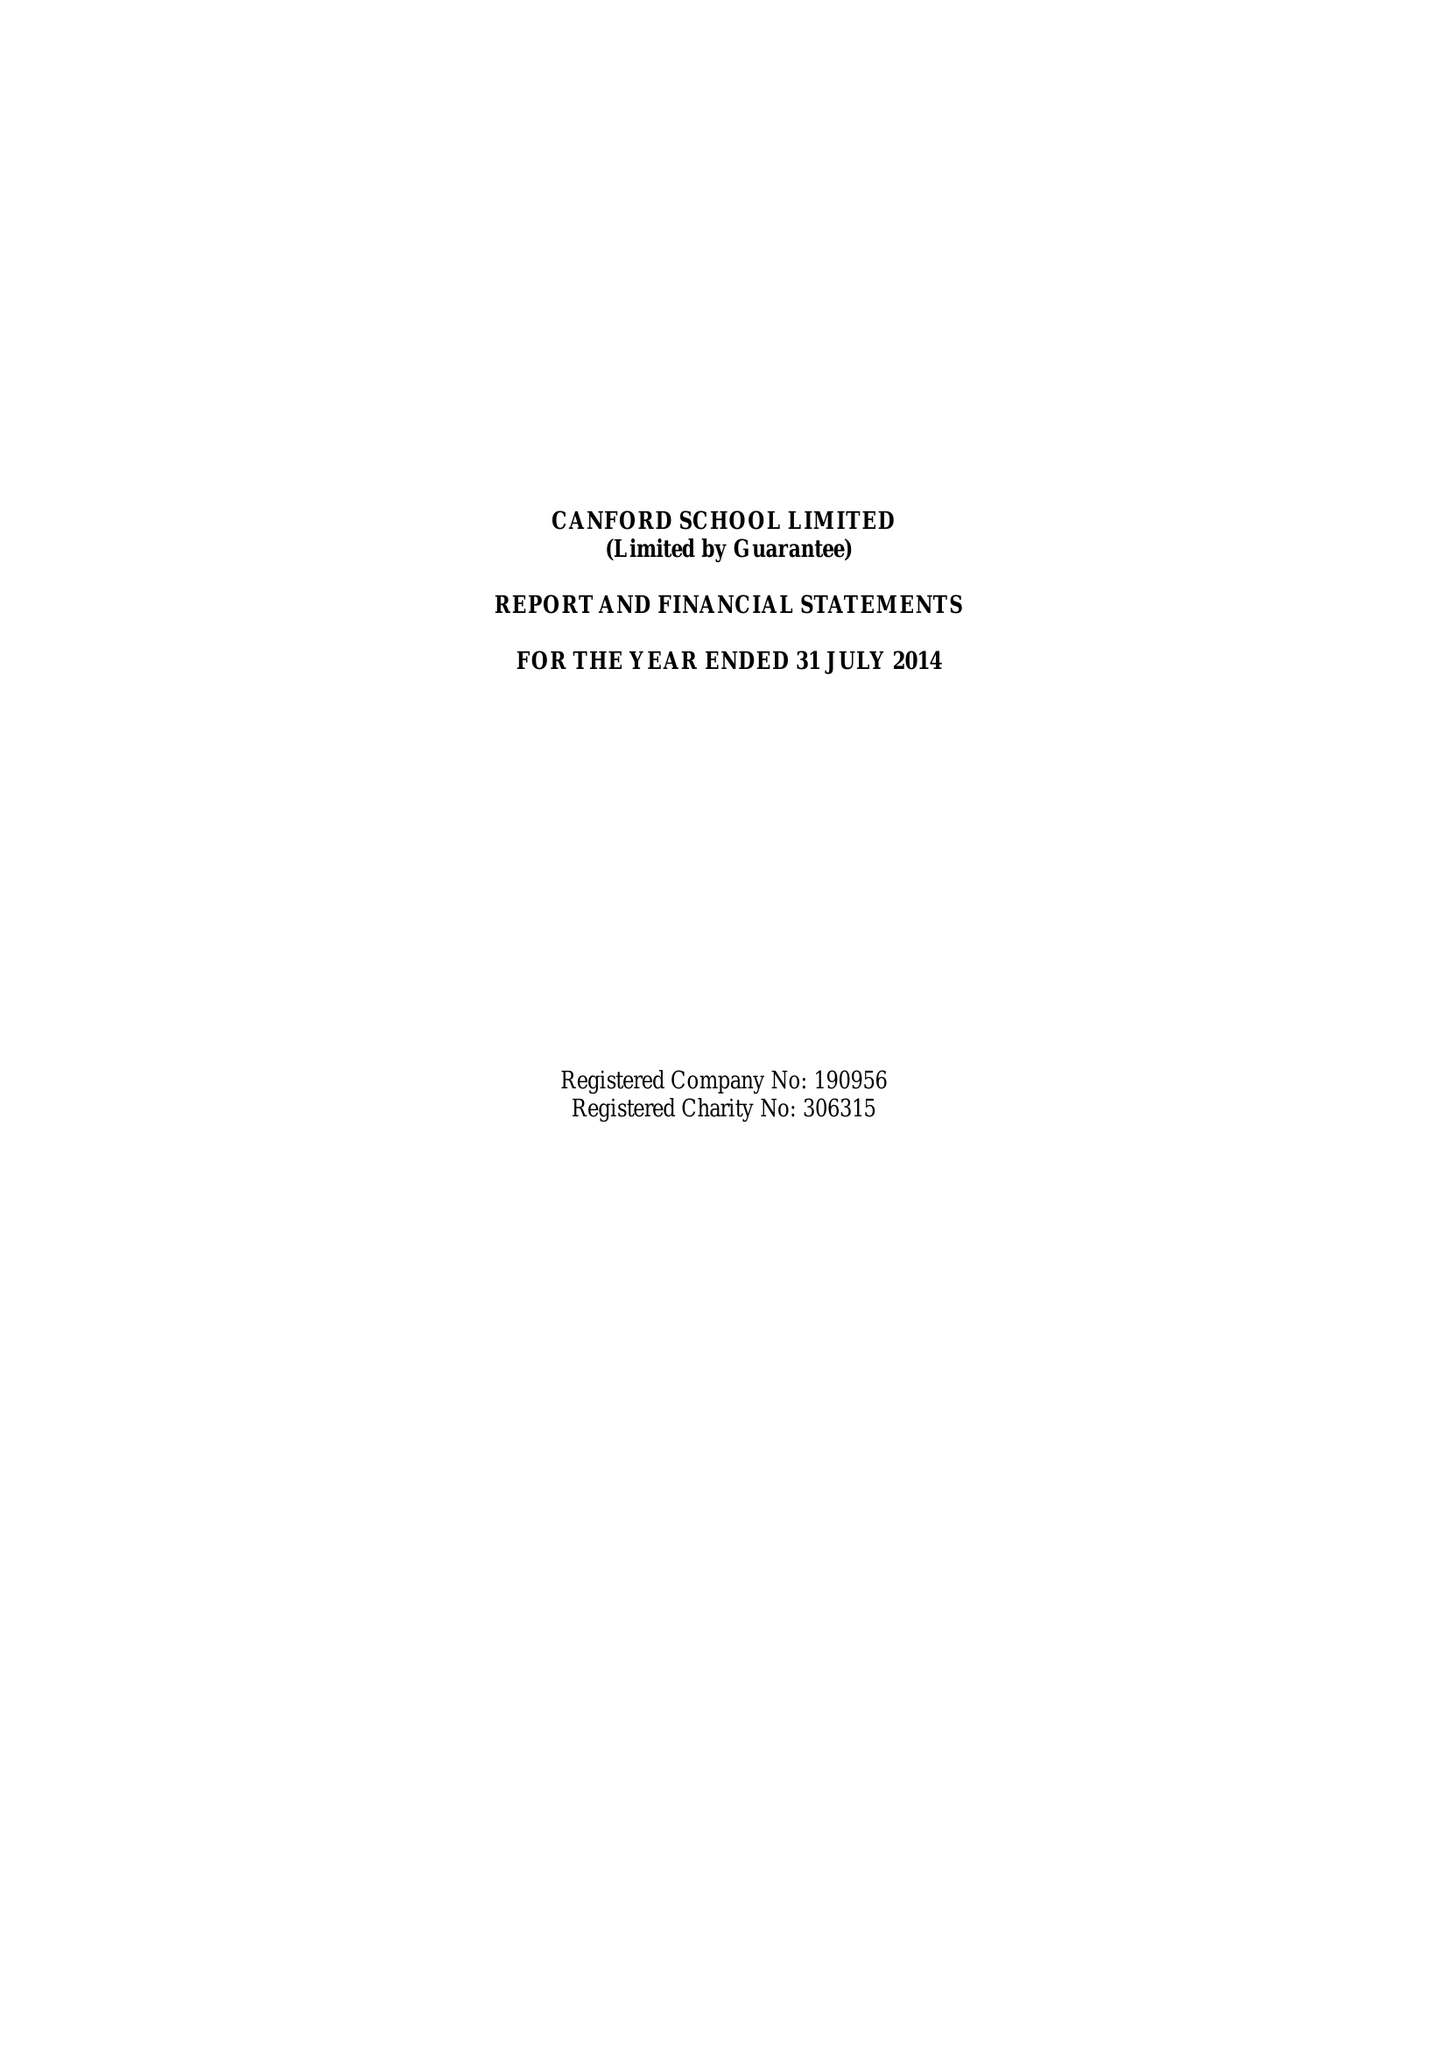What is the value for the charity_name?
Answer the question using a single word or phrase. Canford School Ltd. 